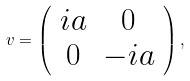<formula> <loc_0><loc_0><loc_500><loc_500>v = \left ( \begin{array} { c c } { i a } & { 0 } \\ { 0 } & { - i a } \end{array} \right ) ,</formula> 